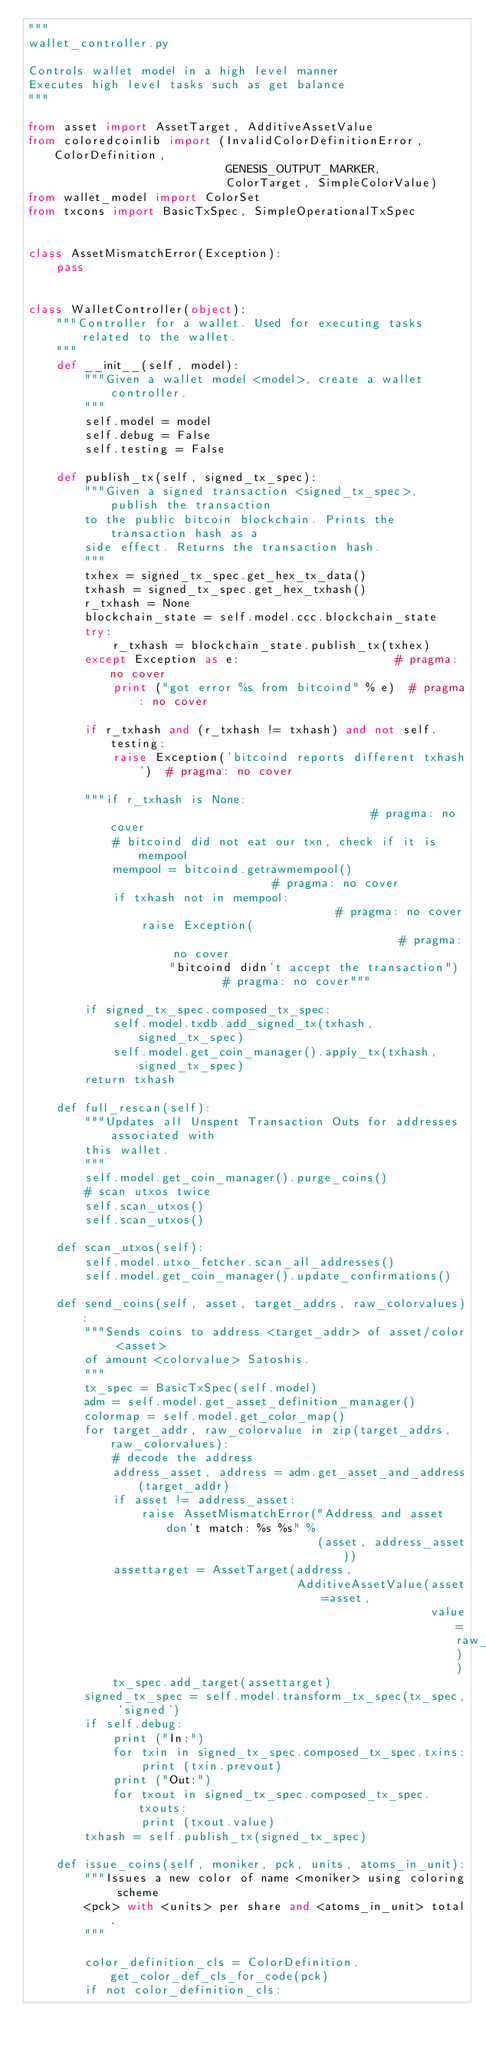Convert code to text. <code><loc_0><loc_0><loc_500><loc_500><_Python_>"""
wallet_controller.py

Controls wallet model in a high level manner
Executes high level tasks such as get balance
"""

from asset import AssetTarget, AdditiveAssetValue
from coloredcoinlib import (InvalidColorDefinitionError, ColorDefinition,
                            GENESIS_OUTPUT_MARKER,
                            ColorTarget, SimpleColorValue)
from wallet_model import ColorSet
from txcons import BasicTxSpec, SimpleOperationalTxSpec


class AssetMismatchError(Exception):
    pass


class WalletController(object):
    """Controller for a wallet. Used for executing tasks related to the wallet.
    """
    def __init__(self, model):
        """Given a wallet model <model>, create a wallet controller.
        """
        self.model = model
        self.debug = False
        self.testing = False

    def publish_tx(self, signed_tx_spec):
        """Given a signed transaction <signed_tx_spec>, publish the transaction
        to the public bitcoin blockchain. Prints the transaction hash as a
        side effect. Returns the transaction hash.
        """
        txhex = signed_tx_spec.get_hex_tx_data()
        txhash = signed_tx_spec.get_hex_txhash()
        r_txhash = None
        blockchain_state = self.model.ccc.blockchain_state
        try:
            r_txhash = blockchain_state.publish_tx(txhex)
        except Exception as e:                      # pragma: no cover
            print ("got error %s from bitcoind" % e)  # pragma: no cover
        
        if r_txhash and (r_txhash != txhash) and not self.testing:
            raise Exception('bitcoind reports different txhash')  # pragma: no cover
        
        """if r_txhash is None:                                      # pragma: no cover
            # bitcoind did not eat our txn, check if it is mempool
            mempool = bitcoind.getrawmempool()                    # pragma: no cover
            if txhash not in mempool:                             # pragma: no cover
                raise Exception(                                  # pragma: no cover
                    "bitcoind didn't accept the transaction")     # pragma: no cover"""

        if signed_tx_spec.composed_tx_spec:
            self.model.txdb.add_signed_tx(txhash, signed_tx_spec)
            self.model.get_coin_manager().apply_tx(txhash, signed_tx_spec)
        return txhash

    def full_rescan(self):
        """Updates all Unspent Transaction Outs for addresses associated with
        this wallet.
        """
        self.model.get_coin_manager().purge_coins()
        # scan utxos twice
        self.scan_utxos()
        self.scan_utxos()

    def scan_utxos(self):
        self.model.utxo_fetcher.scan_all_addresses()
        self.model.get_coin_manager().update_confirmations()

    def send_coins(self, asset, target_addrs, raw_colorvalues):
        """Sends coins to address <target_addr> of asset/color <asset>
        of amount <colorvalue> Satoshis.
        """
        tx_spec = BasicTxSpec(self.model)
        adm = self.model.get_asset_definition_manager()
        colormap = self.model.get_color_map()
        for target_addr, raw_colorvalue in zip(target_addrs, raw_colorvalues):
            # decode the address
            address_asset, address = adm.get_asset_and_address(target_addr)
            if asset != address_asset:
                raise AssetMismatchError("Address and asset don't match: %s %s" %
                                         (asset, address_asset))
            assettarget = AssetTarget(address,
                                      AdditiveAssetValue(asset=asset,
                                                         value=raw_colorvalue))
            tx_spec.add_target(assettarget)
        signed_tx_spec = self.model.transform_tx_spec(tx_spec, 'signed')
        if self.debug:
            print ("In:")
            for txin in signed_tx_spec.composed_tx_spec.txins:
                print (txin.prevout)
            print ("Out:")
            for txout in signed_tx_spec.composed_tx_spec.txouts:
                print (txout.value)
        txhash = self.publish_tx(signed_tx_spec)

    def issue_coins(self, moniker, pck, units, atoms_in_unit):
        """Issues a new color of name <moniker> using coloring scheme
        <pck> with <units> per share and <atoms_in_unit> total.
        """

        color_definition_cls = ColorDefinition.get_color_def_cls_for_code(pck)
        if not color_definition_cls:</code> 